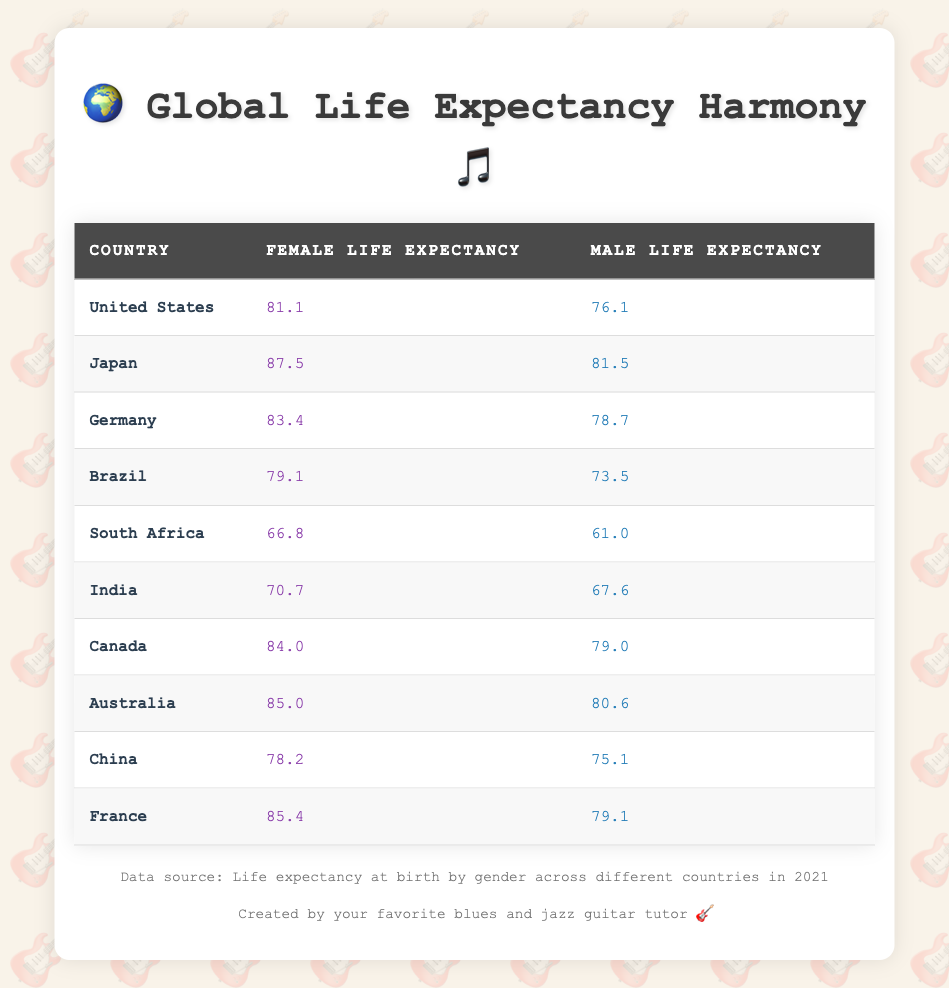What is the life expectancy for females in Japan? The table indicates that the life expectancy for females in Japan is listed as 87.5 years.
Answer: 87.5 What is the difference in life expectancy between males and females in South Africa? For South Africa, females have a life expectancy of 66.8 years and males have 61.0 years. The difference is 66.8 - 61.0 = 5.8 years.
Answer: 5.8 Is the life expectancy for males in Canada higher than for males in Brazil? The life expectancy for males in Canada is 79.0 years while for Brazil it is 73.5 years. Since 79.0 is greater than 73.5, the statement is true.
Answer: Yes What country has the highest female life expectancy, and what is that value? According to the table, Japan has the highest female life expectancy at 87.5 years, which is greater than any other listed country.
Answer: Japan, 87.5 What is the average life expectancy for males across the countries listed? To find the average, we first sum the male life expectancies: 76.1 + 81.5 + 78.7 + 73.5 + 61.0 + 67.6 + 79.0 + 80.6 + 75.1 + 79.1 =  80.6. There are 10 countries, so the average is 80.6 / 10 = 78.06.
Answer: 78.06 Which country has the lowest life expectancy for females, and what is that value? South Africa has the lowest female life expectancy at 66.8 years, as all other listed countries have higher values for females.
Answer: South Africa, 66.8 Is the male life expectancy in Germany higher than in India? In Germany, the male life expectancy is 78.7 years, while in India it is 67.6 years. Since 78.7 is greater than 67.6, the statement is true.
Answer: Yes What is the combined male and female life expectancy for Australia? For Australia, the female life expectancy is 85.0 and male is 80.6. The combined value is 85.0 + 80.6 = 165.6.
Answer: 165.6 